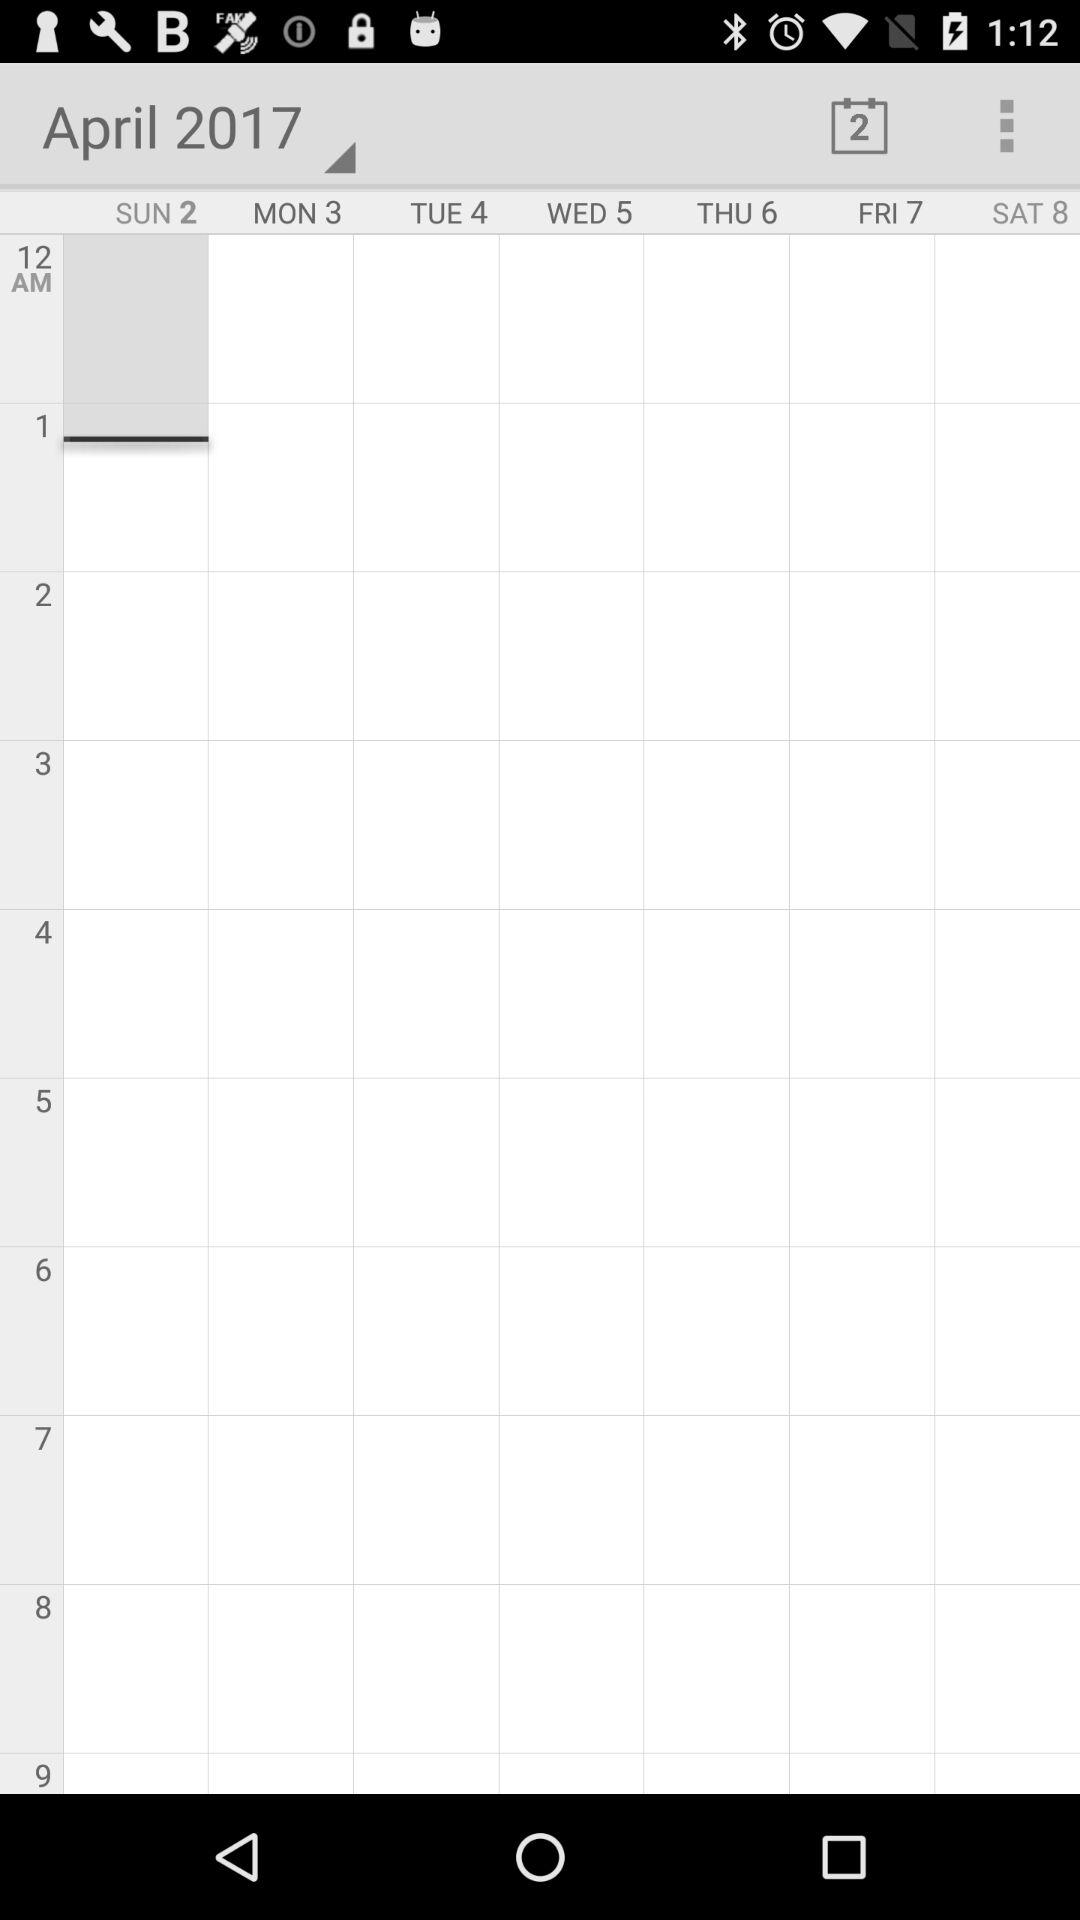What is the day on April 2? The day is Sunday. 